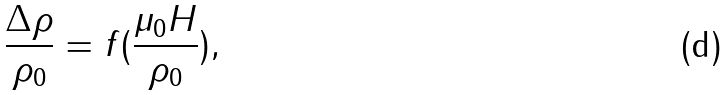Convert formula to latex. <formula><loc_0><loc_0><loc_500><loc_500>\frac { \Delta \rho } { \rho _ { 0 } } = f ( \frac { \mu _ { 0 } H } { \rho _ { 0 } } ) ,</formula> 